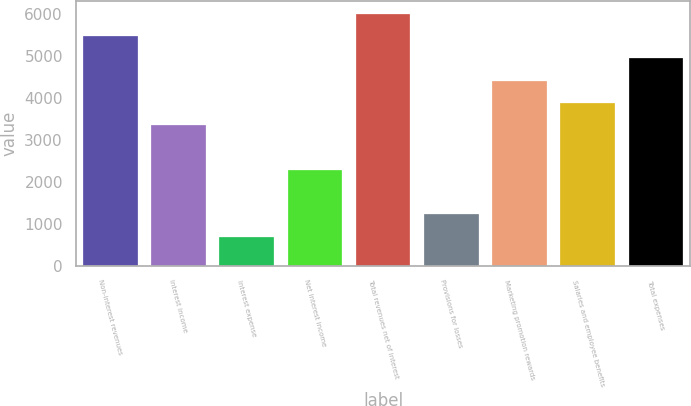Convert chart to OTSL. <chart><loc_0><loc_0><loc_500><loc_500><bar_chart><fcel>Non-interest revenues<fcel>Interest income<fcel>Interest expense<fcel>Net interest income<fcel>Total revenues net of interest<fcel>Provisions for losses<fcel>Marketing promotion rewards<fcel>Salaries and employee benefits<fcel>Total expenses<nl><fcel>5488<fcel>3358<fcel>695.5<fcel>2293<fcel>6020.5<fcel>1228<fcel>4423<fcel>3890.5<fcel>4955.5<nl></chart> 